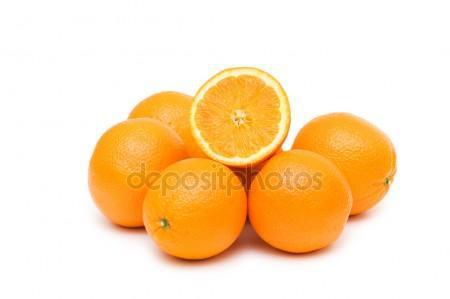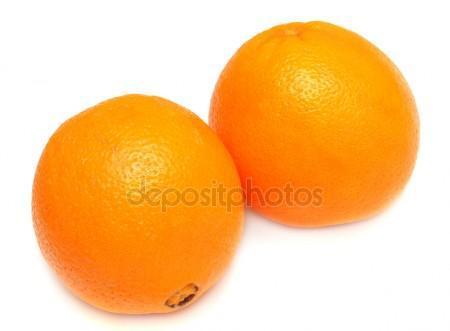The first image is the image on the left, the second image is the image on the right. Given the left and right images, does the statement "There is at least six oranges that are not cut in any way." hold true? Answer yes or no. Yes. The first image is the image on the left, the second image is the image on the right. Given the left and right images, does the statement "One of the images has exactly two uncut oranges without any other fruits present." hold true? Answer yes or no. Yes. 